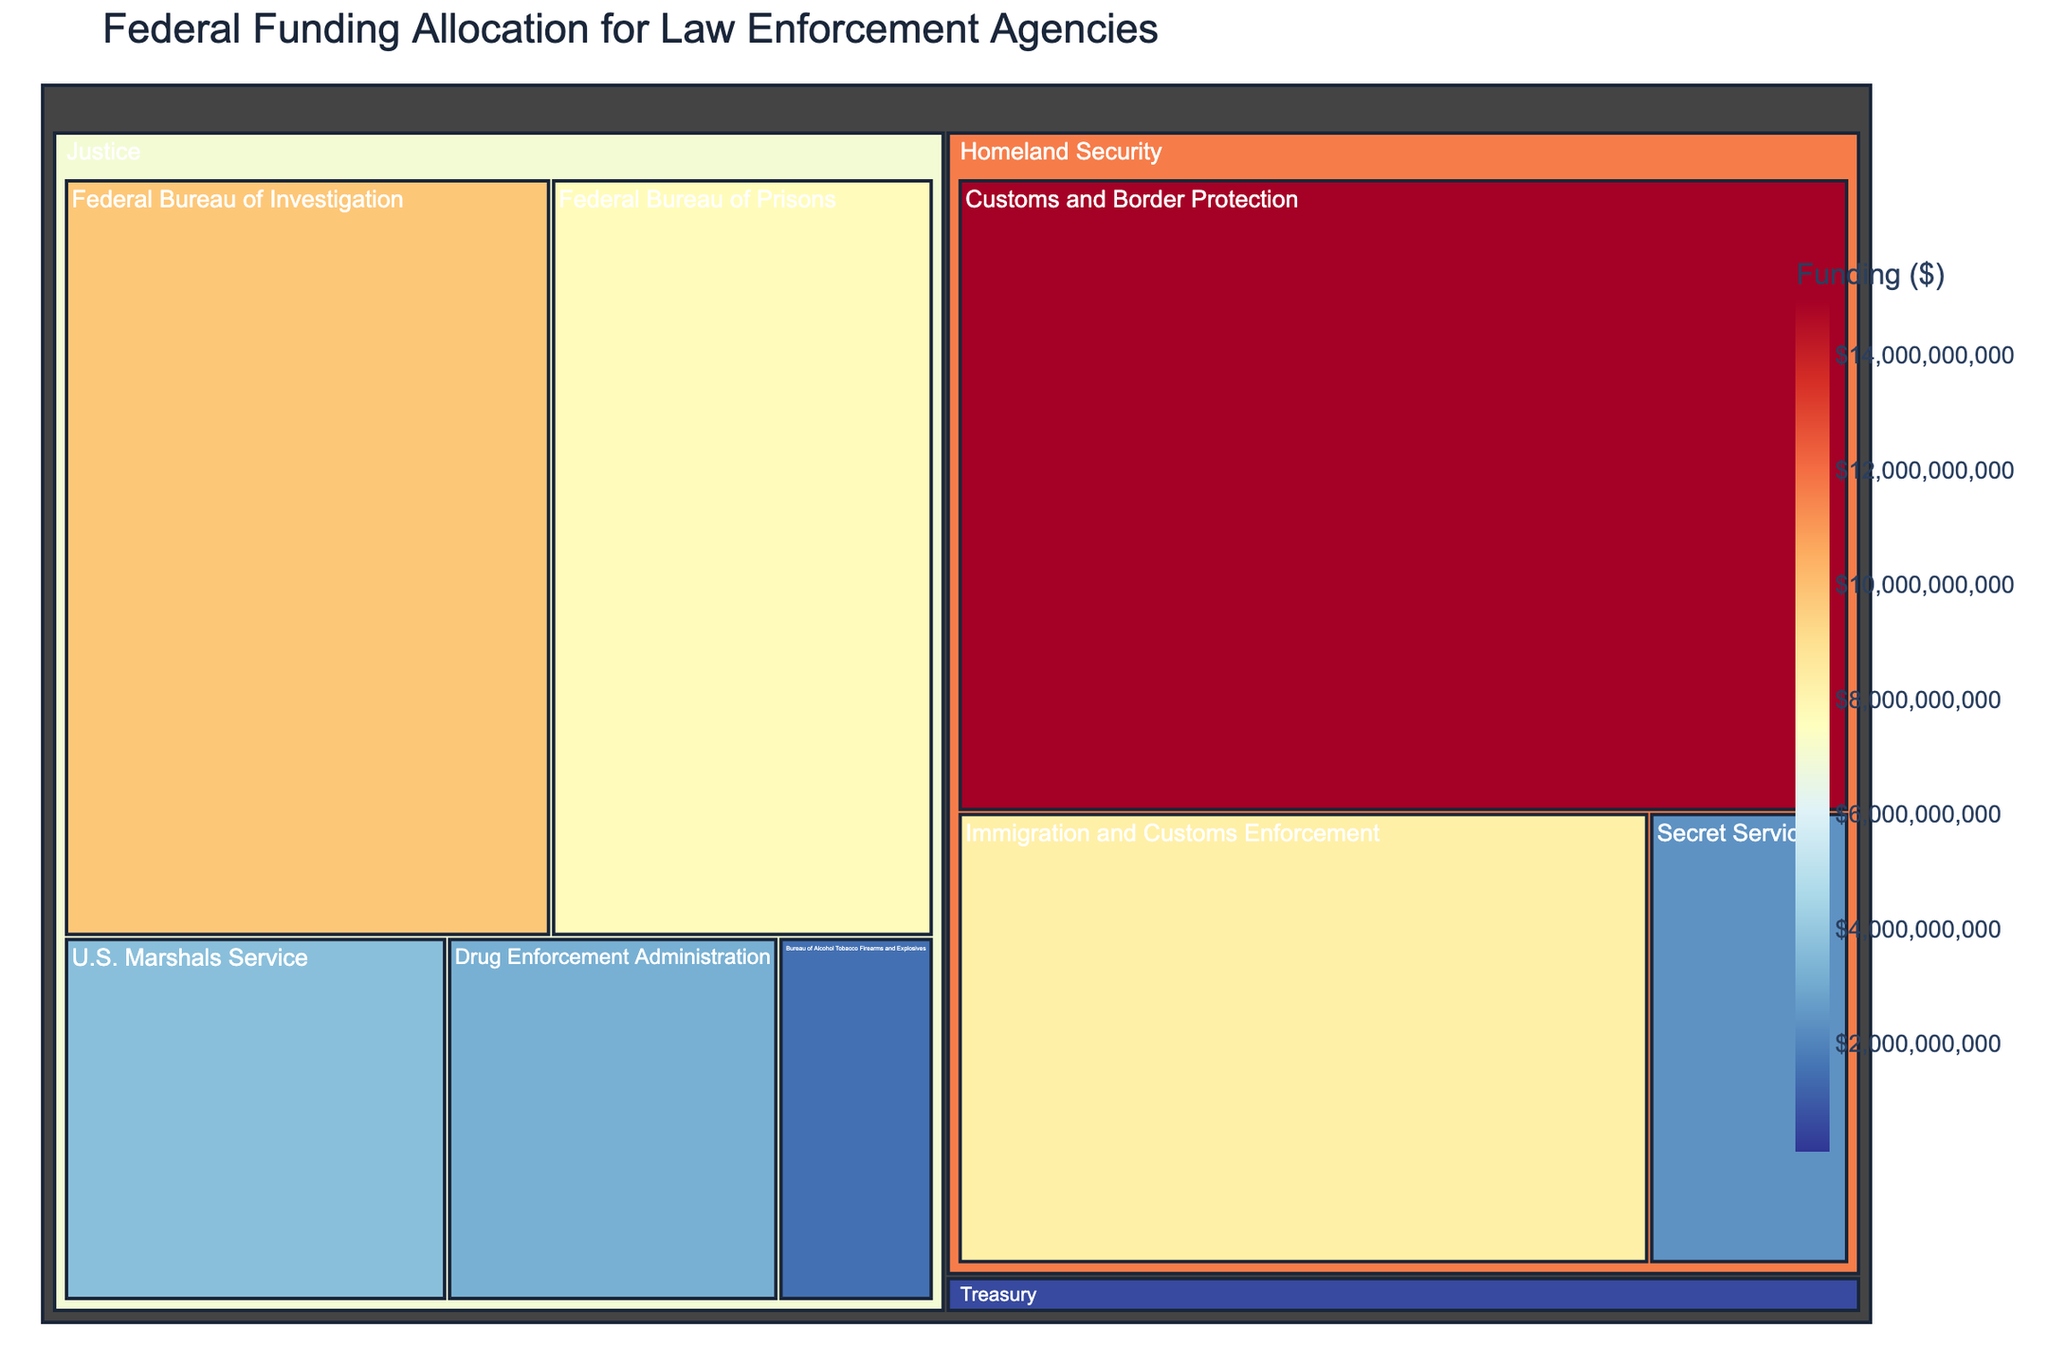What's the highest funded agency in the figure? To find the highest funded agency, look for the largest rectangle in the treemap and check its funding value. "Customs and Border Protection" has a funding of $15,000,000,000 which is the highest.
Answer: Customs and Border Protection Which department has the most agencies listed? Compare the number of agencies under each department. "Justice" has 5 agencies, which is the highest.
Answer: Justice What's the total funding allocated to the Department of Justice? Sum the funding values of all agencies under the Department of Justice: $9,800,000,000 (FBI) + $3,200,000,000 (DEA) + $3,700,000,000 (U.S. Marshals Service) + $1,500,000,000 (ATF) + $7,700,000,000 (Federal Bureau of Prisons) = $25,900,000,000.
Answer: $25,900,000,000 How does the funding for the Internal Revenue Service Criminal Investigation compare to the Federal Bureau of Investigation? Compare the funding amounts: $700,000,000 (IRS Criminal Investigation) vs $9,800,000,000 (FBI). The FBI receives considerably more funding.
Answer: FBI receives more Which agency in the Homeland Security department has the lower funding: "Customs and Border Protection" or "Secret Service"? Compare the funding amounts of the two agencies under Homeland Security: $15,000,000,000 (Customs and Border Protection) vs $2,400,000,000 (Secret Service). The Secret Service has lower funding.
Answer: Secret Service What's the average funding for the agencies classified under the Justice Department? Calculate the average by summing the funding values and dividing by the number of agencies: ($9,800,000,000 + $3,200,000,000 + $3,700,000,000 + $1,500,000,000 + $7,700,000,000) / 5 = $5,180,000,000.
Answer: $5,180,000,000 How many agencies are there in the Treasury Department, and what is their combined funding? Identify the agencies under Treasury: "Internal Revenue Service Criminal Investigation" and "Financial Crimes Enforcement Network". Their combined funding is $700,000,000 + $130,000,000 = $830,000,000.
Answer: 2 agencies, $830,000,000 What's the funding difference between the highest and lowest funded agencies? Subtract the lowest funding value from the highest: $15,000,000,000 (highest, Customs and Border Protection) - $130,000,000 (lowest, Financial Crimes Enforcement Network) = $14,870,000,000.
Answer: $14,870,000,000 